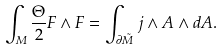Convert formula to latex. <formula><loc_0><loc_0><loc_500><loc_500>\int _ { M } \frac { \Theta } { 2 } F \wedge F = \int _ { \partial \tilde { M } } j \wedge A \wedge d A .</formula> 